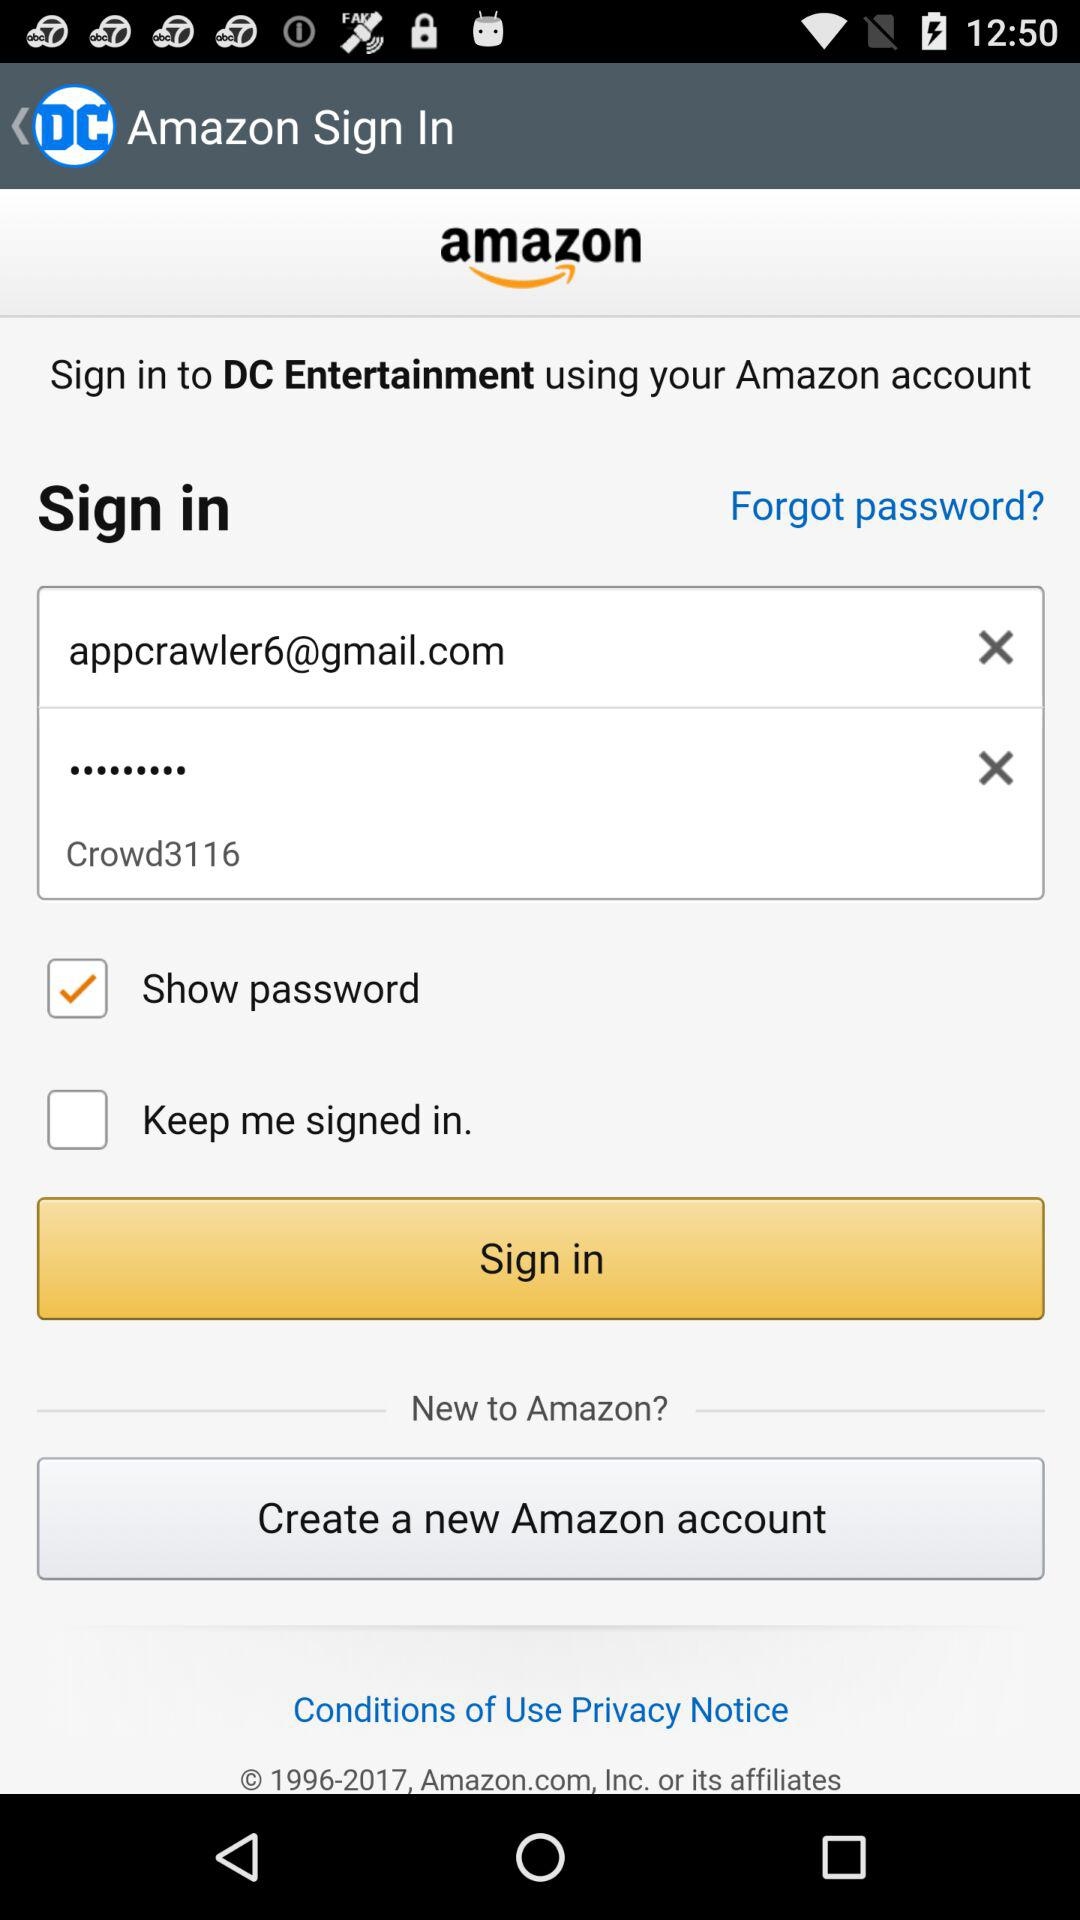How many text fields are there in the sign in form?
Answer the question using a single word or phrase. 2 